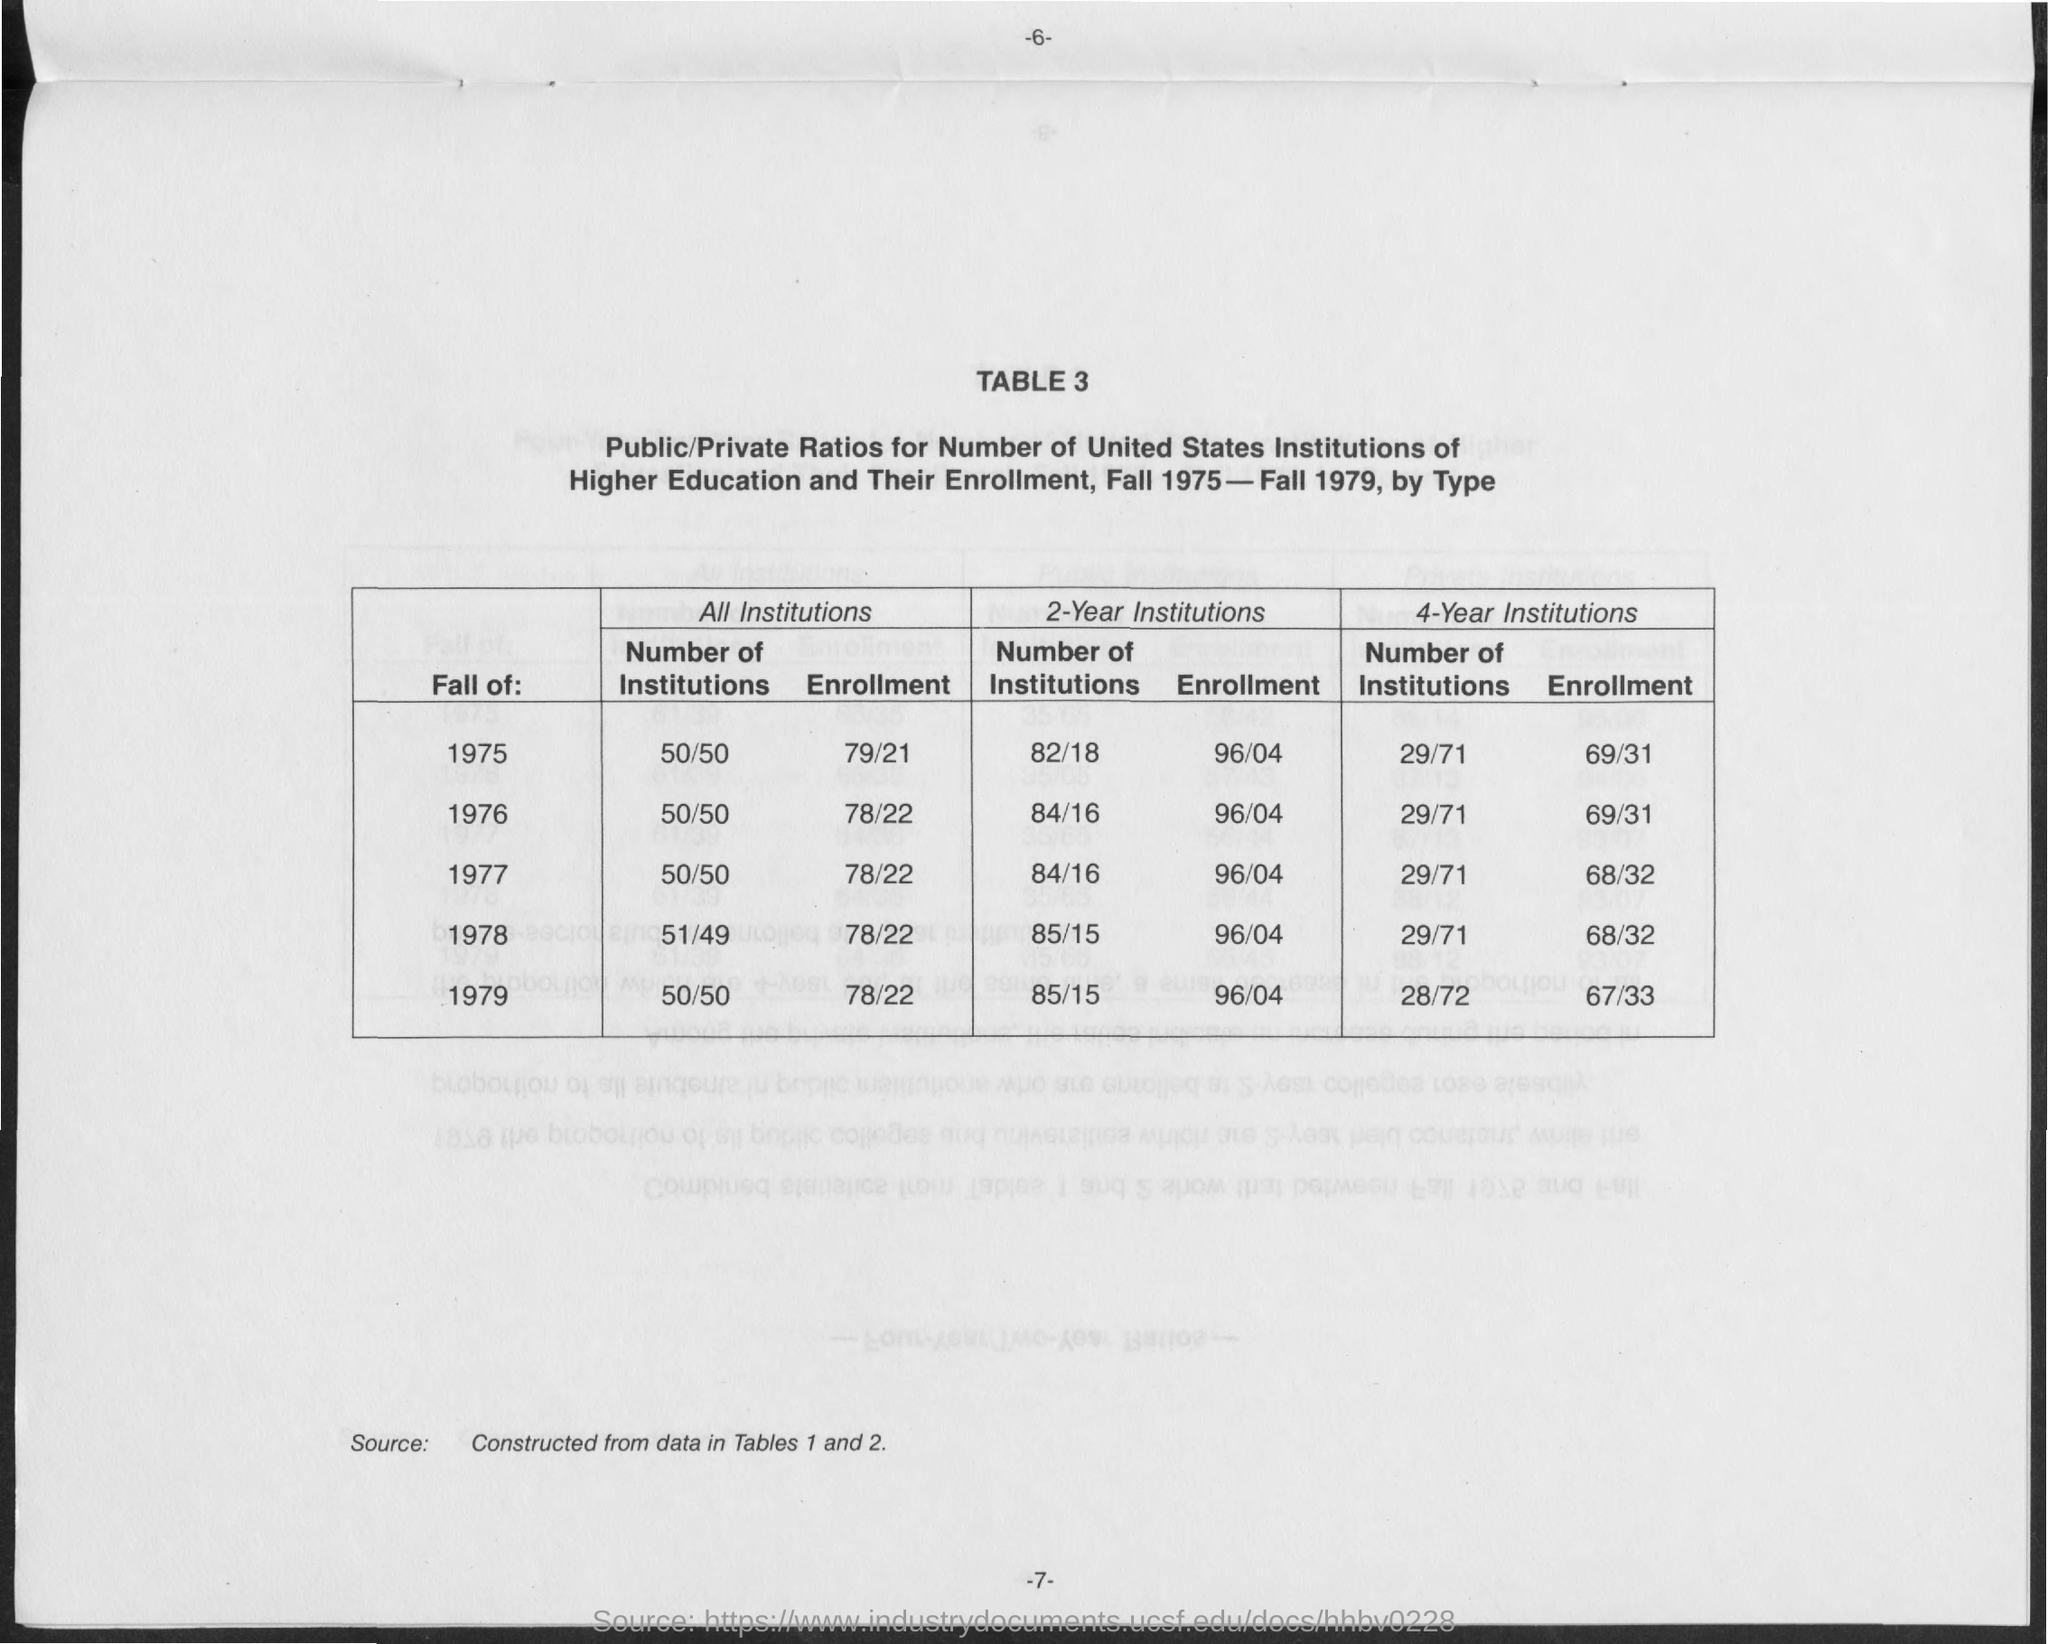What is the value of enrollment for all institutions in fall of 1975?
Provide a succinct answer. 79/21. What is the value of enrollment for all institutions in fall of 1976?
Ensure brevity in your answer.  78/22. What is the value of enrollment for all institutions in fall of 1977?
Provide a short and direct response. 78/22. What is the value of enrollment for all institutions in fall of 1978?
Provide a succinct answer. 78/22. What is the value of enrollment for all institutions in fall of 1979?
Your response must be concise. 78/22. What is the value of enrollment for 2-Year institutions in fall of 1975?
Offer a very short reply. 96/04. What is the value of enrollment for 2-Year institutions in fall of 1976?
Make the answer very short. 96/04. What is the value of enrollment for 2-Year institutions in fall of 1977?
Ensure brevity in your answer.  96/04. What is the value of enrollment for 2-Year institutions in fall of 1978?
Provide a short and direct response. 96/04. What is the value of enrollment for 2-Year institutions in fall of 1979?
Provide a short and direct response. 96/04. 